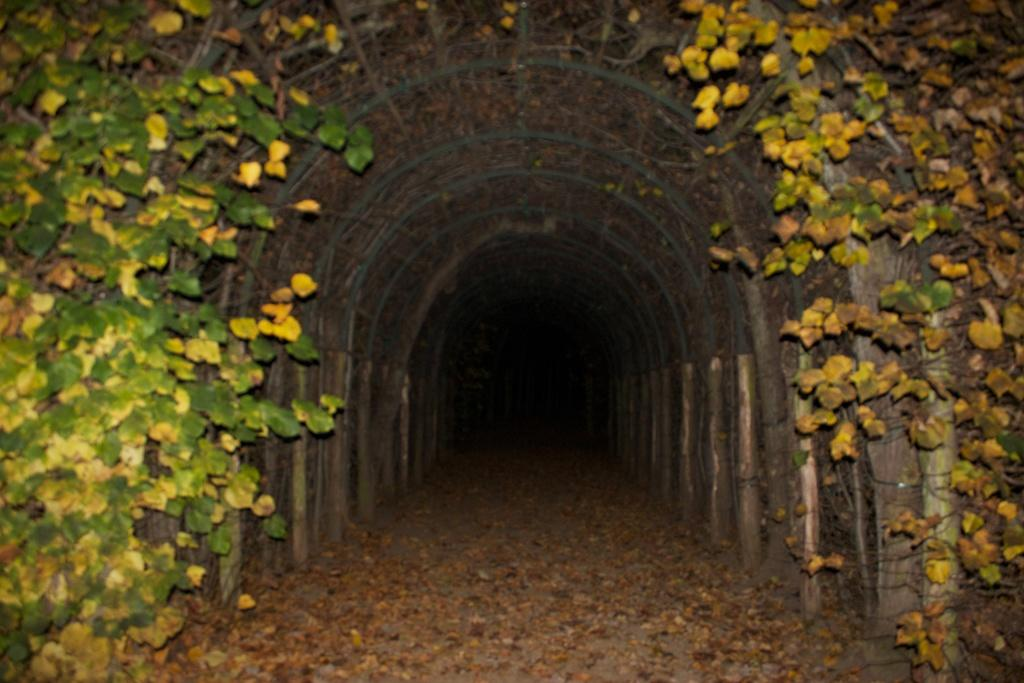What structure can be seen in the image? There is an arch in the image. What is growing on the arch? Vine plants are present on the arch. What colors of leaves can be seen on the sides of the image? There are green and yellow leaves on the left and right sides of the image. What is visible on the ground at the bottom of the image? Dry leaves are visible on the floor at the bottom of the image. What type of disease is affecting the chickens in the image? There are no chickens present in the image, so it is not possible to determine if any disease is affecting them. 